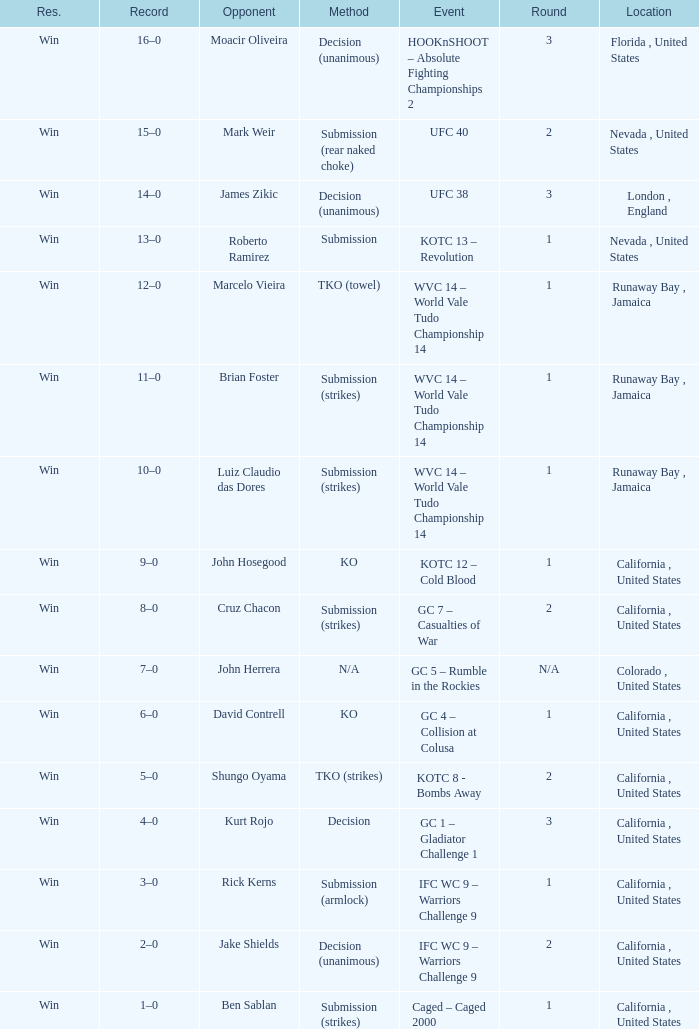Where was the fight located that lasted 1 round against luiz claudio das dores? Runaway Bay , Jamaica. 